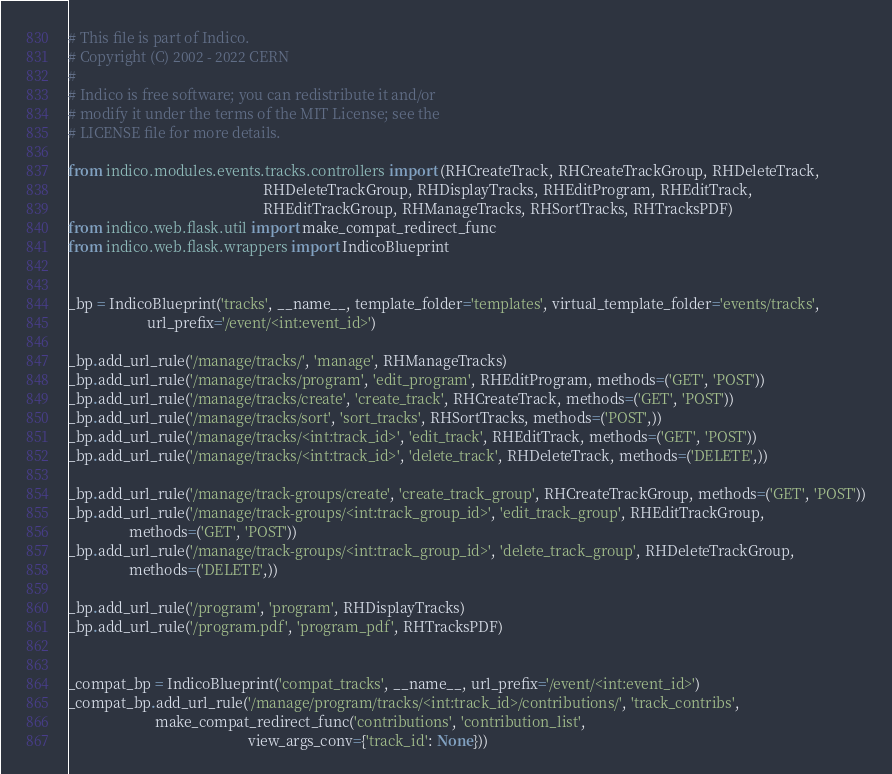<code> <loc_0><loc_0><loc_500><loc_500><_Python_># This file is part of Indico.
# Copyright (C) 2002 - 2022 CERN
#
# Indico is free software; you can redistribute it and/or
# modify it under the terms of the MIT License; see the
# LICENSE file for more details.

from indico.modules.events.tracks.controllers import (RHCreateTrack, RHCreateTrackGroup, RHDeleteTrack,
                                                      RHDeleteTrackGroup, RHDisplayTracks, RHEditProgram, RHEditTrack,
                                                      RHEditTrackGroup, RHManageTracks, RHSortTracks, RHTracksPDF)
from indico.web.flask.util import make_compat_redirect_func
from indico.web.flask.wrappers import IndicoBlueprint


_bp = IndicoBlueprint('tracks', __name__, template_folder='templates', virtual_template_folder='events/tracks',
                      url_prefix='/event/<int:event_id>')

_bp.add_url_rule('/manage/tracks/', 'manage', RHManageTracks)
_bp.add_url_rule('/manage/tracks/program', 'edit_program', RHEditProgram, methods=('GET', 'POST'))
_bp.add_url_rule('/manage/tracks/create', 'create_track', RHCreateTrack, methods=('GET', 'POST'))
_bp.add_url_rule('/manage/tracks/sort', 'sort_tracks', RHSortTracks, methods=('POST',))
_bp.add_url_rule('/manage/tracks/<int:track_id>', 'edit_track', RHEditTrack, methods=('GET', 'POST'))
_bp.add_url_rule('/manage/tracks/<int:track_id>', 'delete_track', RHDeleteTrack, methods=('DELETE',))

_bp.add_url_rule('/manage/track-groups/create', 'create_track_group', RHCreateTrackGroup, methods=('GET', 'POST'))
_bp.add_url_rule('/manage/track-groups/<int:track_group_id>', 'edit_track_group', RHEditTrackGroup,
                 methods=('GET', 'POST'))
_bp.add_url_rule('/manage/track-groups/<int:track_group_id>', 'delete_track_group', RHDeleteTrackGroup,
                 methods=('DELETE',))

_bp.add_url_rule('/program', 'program', RHDisplayTracks)
_bp.add_url_rule('/program.pdf', 'program_pdf', RHTracksPDF)


_compat_bp = IndicoBlueprint('compat_tracks', __name__, url_prefix='/event/<int:event_id>')
_compat_bp.add_url_rule('/manage/program/tracks/<int:track_id>/contributions/', 'track_contribs',
                        make_compat_redirect_func('contributions', 'contribution_list',
                                                  view_args_conv={'track_id': None}))
</code> 